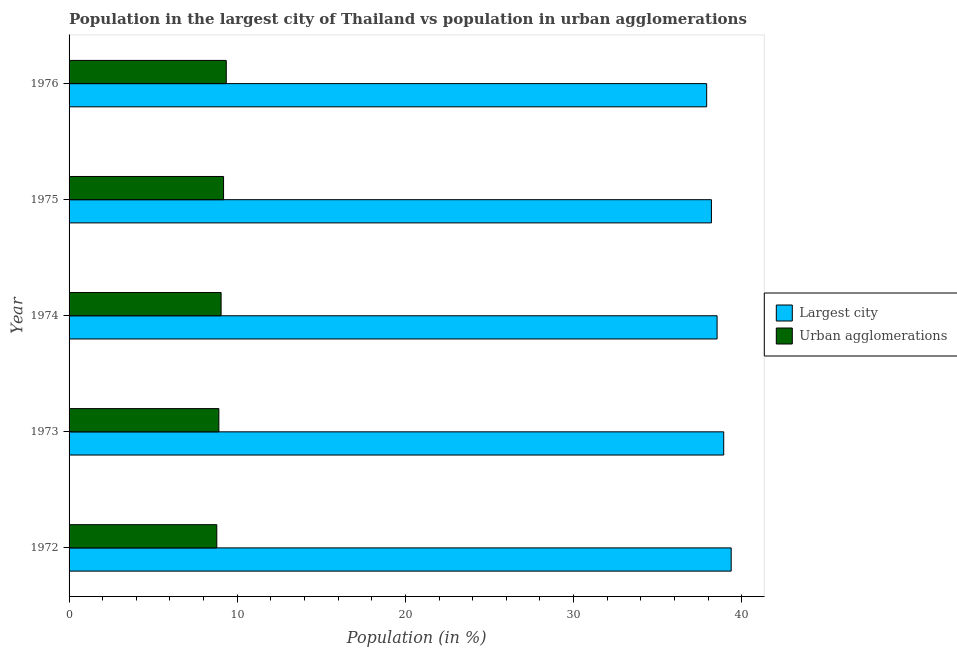How many groups of bars are there?
Offer a terse response. 5. Are the number of bars on each tick of the Y-axis equal?
Offer a very short reply. Yes. What is the label of the 1st group of bars from the top?
Provide a succinct answer. 1976. What is the population in urban agglomerations in 1972?
Your answer should be compact. 8.78. Across all years, what is the maximum population in urban agglomerations?
Make the answer very short. 9.35. Across all years, what is the minimum population in the largest city?
Make the answer very short. 37.92. In which year was the population in the largest city maximum?
Offer a terse response. 1972. What is the total population in urban agglomerations in the graph?
Provide a short and direct response. 45.27. What is the difference between the population in urban agglomerations in 1975 and that in 1976?
Your response must be concise. -0.16. What is the difference between the population in urban agglomerations in 1976 and the population in the largest city in 1973?
Your response must be concise. -29.58. What is the average population in the largest city per year?
Your response must be concise. 38.59. In the year 1975, what is the difference between the population in urban agglomerations and population in the largest city?
Ensure brevity in your answer.  -29.01. What is the ratio of the population in urban agglomerations in 1974 to that in 1976?
Offer a terse response. 0.97. Is the population in the largest city in 1972 less than that in 1976?
Offer a terse response. No. Is the difference between the population in urban agglomerations in 1973 and 1975 greater than the difference between the population in the largest city in 1973 and 1975?
Your answer should be very brief. No. What is the difference between the highest and the second highest population in the largest city?
Ensure brevity in your answer.  0.44. What is the difference between the highest and the lowest population in the largest city?
Your response must be concise. 1.46. What does the 2nd bar from the top in 1974 represents?
Your answer should be very brief. Largest city. What does the 2nd bar from the bottom in 1974 represents?
Your answer should be very brief. Urban agglomerations. How many bars are there?
Make the answer very short. 10. Are all the bars in the graph horizontal?
Make the answer very short. Yes. What is the difference between two consecutive major ticks on the X-axis?
Make the answer very short. 10. Are the values on the major ticks of X-axis written in scientific E-notation?
Give a very brief answer. No. Does the graph contain grids?
Make the answer very short. No. How are the legend labels stacked?
Your answer should be very brief. Vertical. What is the title of the graph?
Your answer should be very brief. Population in the largest city of Thailand vs population in urban agglomerations. Does "Register a business" appear as one of the legend labels in the graph?
Make the answer very short. No. What is the label or title of the X-axis?
Provide a succinct answer. Population (in %). What is the label or title of the Y-axis?
Give a very brief answer. Year. What is the Population (in %) in Largest city in 1972?
Ensure brevity in your answer.  39.37. What is the Population (in %) in Urban agglomerations in 1972?
Ensure brevity in your answer.  8.78. What is the Population (in %) of Largest city in 1973?
Your answer should be very brief. 38.93. What is the Population (in %) in Urban agglomerations in 1973?
Your response must be concise. 8.91. What is the Population (in %) of Largest city in 1974?
Give a very brief answer. 38.54. What is the Population (in %) in Urban agglomerations in 1974?
Your response must be concise. 9.04. What is the Population (in %) in Largest city in 1975?
Make the answer very short. 38.2. What is the Population (in %) of Urban agglomerations in 1975?
Keep it short and to the point. 9.19. What is the Population (in %) of Largest city in 1976?
Provide a short and direct response. 37.92. What is the Population (in %) of Urban agglomerations in 1976?
Ensure brevity in your answer.  9.35. Across all years, what is the maximum Population (in %) in Largest city?
Offer a very short reply. 39.37. Across all years, what is the maximum Population (in %) of Urban agglomerations?
Your answer should be very brief. 9.35. Across all years, what is the minimum Population (in %) in Largest city?
Give a very brief answer. 37.92. Across all years, what is the minimum Population (in %) of Urban agglomerations?
Your response must be concise. 8.78. What is the total Population (in %) of Largest city in the graph?
Your answer should be compact. 192.95. What is the total Population (in %) of Urban agglomerations in the graph?
Make the answer very short. 45.27. What is the difference between the Population (in %) of Largest city in 1972 and that in 1973?
Your answer should be very brief. 0.44. What is the difference between the Population (in %) in Urban agglomerations in 1972 and that in 1973?
Provide a succinct answer. -0.12. What is the difference between the Population (in %) in Largest city in 1972 and that in 1974?
Offer a terse response. 0.84. What is the difference between the Population (in %) in Urban agglomerations in 1972 and that in 1974?
Provide a succinct answer. -0.26. What is the difference between the Population (in %) of Largest city in 1972 and that in 1975?
Provide a short and direct response. 1.17. What is the difference between the Population (in %) in Urban agglomerations in 1972 and that in 1975?
Provide a succinct answer. -0.4. What is the difference between the Population (in %) of Largest city in 1972 and that in 1976?
Offer a terse response. 1.46. What is the difference between the Population (in %) of Urban agglomerations in 1972 and that in 1976?
Provide a succinct answer. -0.56. What is the difference between the Population (in %) in Largest city in 1973 and that in 1974?
Your response must be concise. 0.39. What is the difference between the Population (in %) in Urban agglomerations in 1973 and that in 1974?
Offer a terse response. -0.13. What is the difference between the Population (in %) of Largest city in 1973 and that in 1975?
Offer a terse response. 0.73. What is the difference between the Population (in %) of Urban agglomerations in 1973 and that in 1975?
Offer a very short reply. -0.28. What is the difference between the Population (in %) of Largest city in 1973 and that in 1976?
Give a very brief answer. 1.01. What is the difference between the Population (in %) in Urban agglomerations in 1973 and that in 1976?
Offer a very short reply. -0.44. What is the difference between the Population (in %) in Largest city in 1974 and that in 1975?
Ensure brevity in your answer.  0.34. What is the difference between the Population (in %) in Urban agglomerations in 1974 and that in 1975?
Offer a terse response. -0.15. What is the difference between the Population (in %) of Largest city in 1974 and that in 1976?
Provide a succinct answer. 0.62. What is the difference between the Population (in %) of Urban agglomerations in 1974 and that in 1976?
Provide a succinct answer. -0.31. What is the difference between the Population (in %) of Largest city in 1975 and that in 1976?
Keep it short and to the point. 0.28. What is the difference between the Population (in %) in Urban agglomerations in 1975 and that in 1976?
Provide a succinct answer. -0.16. What is the difference between the Population (in %) of Largest city in 1972 and the Population (in %) of Urban agglomerations in 1973?
Give a very brief answer. 30.47. What is the difference between the Population (in %) of Largest city in 1972 and the Population (in %) of Urban agglomerations in 1974?
Ensure brevity in your answer.  30.33. What is the difference between the Population (in %) of Largest city in 1972 and the Population (in %) of Urban agglomerations in 1975?
Your response must be concise. 30.19. What is the difference between the Population (in %) of Largest city in 1972 and the Population (in %) of Urban agglomerations in 1976?
Offer a terse response. 30.03. What is the difference between the Population (in %) in Largest city in 1973 and the Population (in %) in Urban agglomerations in 1974?
Make the answer very short. 29.89. What is the difference between the Population (in %) in Largest city in 1973 and the Population (in %) in Urban agglomerations in 1975?
Provide a succinct answer. 29.74. What is the difference between the Population (in %) in Largest city in 1973 and the Population (in %) in Urban agglomerations in 1976?
Ensure brevity in your answer.  29.58. What is the difference between the Population (in %) of Largest city in 1974 and the Population (in %) of Urban agglomerations in 1975?
Offer a very short reply. 29.35. What is the difference between the Population (in %) in Largest city in 1974 and the Population (in %) in Urban agglomerations in 1976?
Provide a short and direct response. 29.19. What is the difference between the Population (in %) in Largest city in 1975 and the Population (in %) in Urban agglomerations in 1976?
Provide a succinct answer. 28.85. What is the average Population (in %) of Largest city per year?
Offer a terse response. 38.59. What is the average Population (in %) in Urban agglomerations per year?
Provide a short and direct response. 9.05. In the year 1972, what is the difference between the Population (in %) in Largest city and Population (in %) in Urban agglomerations?
Offer a terse response. 30.59. In the year 1973, what is the difference between the Population (in %) in Largest city and Population (in %) in Urban agglomerations?
Offer a terse response. 30.02. In the year 1974, what is the difference between the Population (in %) of Largest city and Population (in %) of Urban agglomerations?
Your answer should be very brief. 29.49. In the year 1975, what is the difference between the Population (in %) of Largest city and Population (in %) of Urban agglomerations?
Ensure brevity in your answer.  29.01. In the year 1976, what is the difference between the Population (in %) in Largest city and Population (in %) in Urban agglomerations?
Ensure brevity in your answer.  28.57. What is the ratio of the Population (in %) in Largest city in 1972 to that in 1973?
Offer a terse response. 1.01. What is the ratio of the Population (in %) in Urban agglomerations in 1972 to that in 1973?
Provide a succinct answer. 0.99. What is the ratio of the Population (in %) of Largest city in 1972 to that in 1974?
Your response must be concise. 1.02. What is the ratio of the Population (in %) in Urban agglomerations in 1972 to that in 1974?
Your answer should be very brief. 0.97. What is the ratio of the Population (in %) in Largest city in 1972 to that in 1975?
Your answer should be very brief. 1.03. What is the ratio of the Population (in %) of Urban agglomerations in 1972 to that in 1975?
Your answer should be compact. 0.96. What is the ratio of the Population (in %) of Largest city in 1972 to that in 1976?
Your response must be concise. 1.04. What is the ratio of the Population (in %) of Urban agglomerations in 1972 to that in 1976?
Ensure brevity in your answer.  0.94. What is the ratio of the Population (in %) of Largest city in 1973 to that in 1974?
Provide a short and direct response. 1.01. What is the ratio of the Population (in %) in Urban agglomerations in 1973 to that in 1974?
Your answer should be compact. 0.99. What is the ratio of the Population (in %) in Largest city in 1973 to that in 1975?
Your response must be concise. 1.02. What is the ratio of the Population (in %) of Urban agglomerations in 1973 to that in 1975?
Your answer should be compact. 0.97. What is the ratio of the Population (in %) of Largest city in 1973 to that in 1976?
Provide a succinct answer. 1.03. What is the ratio of the Population (in %) in Urban agglomerations in 1973 to that in 1976?
Ensure brevity in your answer.  0.95. What is the ratio of the Population (in %) of Largest city in 1974 to that in 1975?
Offer a terse response. 1.01. What is the ratio of the Population (in %) of Urban agglomerations in 1974 to that in 1975?
Your answer should be very brief. 0.98. What is the ratio of the Population (in %) of Largest city in 1974 to that in 1976?
Offer a terse response. 1.02. What is the ratio of the Population (in %) of Urban agglomerations in 1974 to that in 1976?
Ensure brevity in your answer.  0.97. What is the ratio of the Population (in %) in Largest city in 1975 to that in 1976?
Your response must be concise. 1.01. What is the ratio of the Population (in %) of Urban agglomerations in 1975 to that in 1976?
Your response must be concise. 0.98. What is the difference between the highest and the second highest Population (in %) of Largest city?
Give a very brief answer. 0.44. What is the difference between the highest and the second highest Population (in %) in Urban agglomerations?
Your response must be concise. 0.16. What is the difference between the highest and the lowest Population (in %) in Largest city?
Ensure brevity in your answer.  1.46. What is the difference between the highest and the lowest Population (in %) of Urban agglomerations?
Your answer should be very brief. 0.56. 